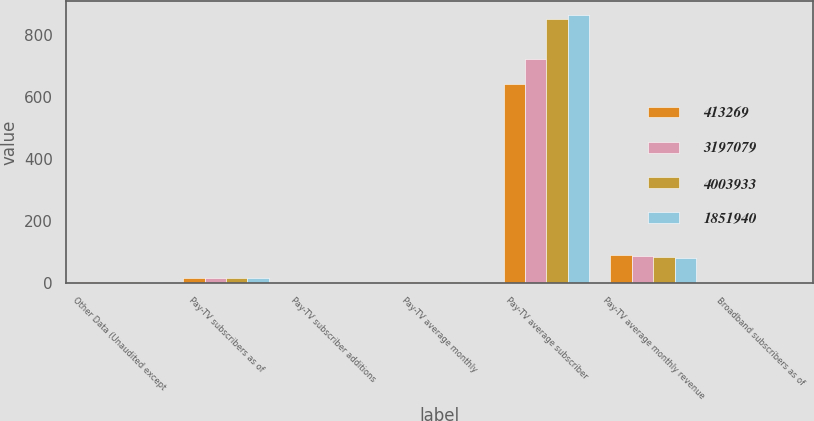<chart> <loc_0><loc_0><loc_500><loc_500><stacked_bar_chart><ecel><fcel>Other Data (Unaudited except<fcel>Pay-TV subscribers as of<fcel>Pay-TV subscriber additions<fcel>Pay-TV average monthly<fcel>Pay-TV average subscriber<fcel>Pay-TV average monthly revenue<fcel>Broadband subscribers as of<nl><fcel>413269<fcel>2.64<fcel>13.67<fcel>0.39<fcel>1.83<fcel>643<fcel>88.66<fcel>0.58<nl><fcel>3.19708e+06<fcel>2.64<fcel>13.9<fcel>0.08<fcel>1.71<fcel>723<fcel>86.79<fcel>0.62<nl><fcel>4.00393e+06<fcel>2.64<fcel>13.98<fcel>0.08<fcel>1.59<fcel>853<fcel>83.77<fcel>0.58<nl><fcel>1.85194e+06<fcel>2.64<fcel>14.06<fcel>0<fcel>1.58<fcel>866<fcel>80.37<fcel>0.44<nl></chart> 